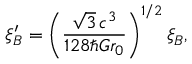<formula> <loc_0><loc_0><loc_500><loc_500>\xi _ { B } ^ { \prime } = \left ( \frac { \sqrt { 3 } \, c ^ { 3 } } { 1 2 8 \hbar { G } r _ { 0 } } \right ) ^ { 1 / 2 } \xi _ { B } ,</formula> 